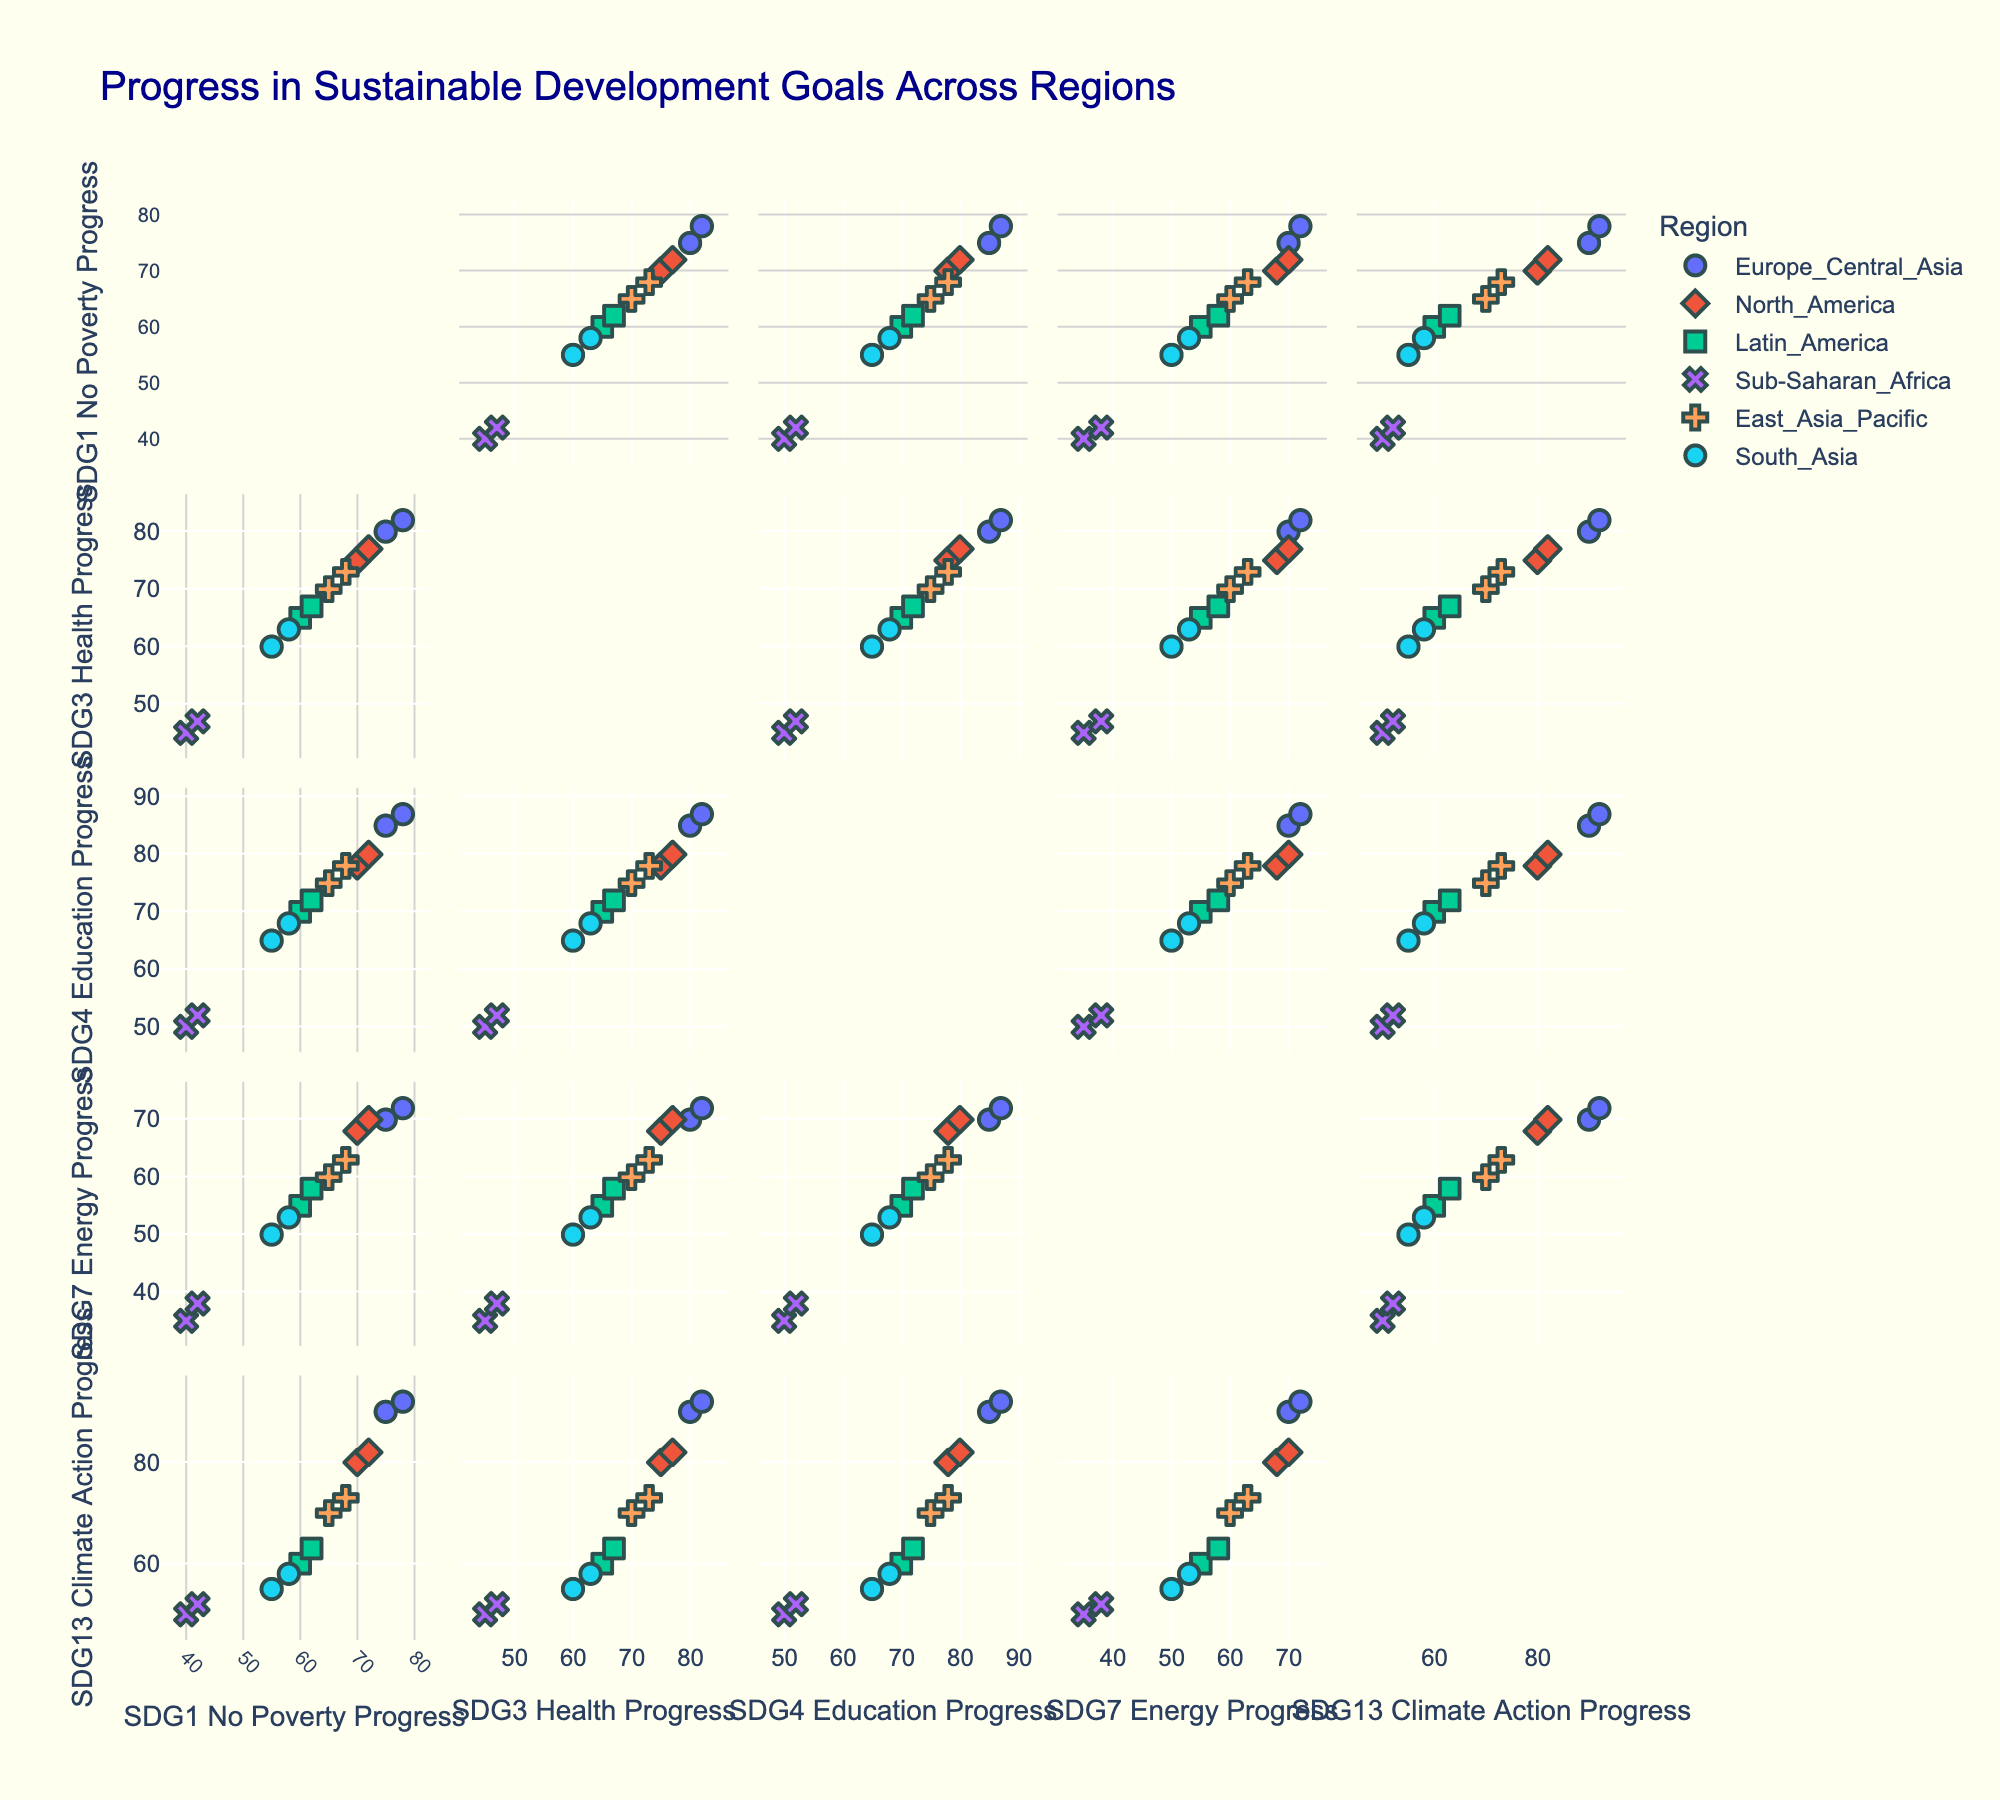What is the title of the figure? The title of the figure is typically displayed at the top of the plot. By looking at the top of the Scatter Plot Matrix (SPLOM), we can read the text indicating the title.
Answer: Progress in Sustainable Development Goals Across Regions How is the `Region` information encoded in the plot? In the Scatter Plot Matrix (SPLOM), the `Region` information is encoded using colors and symbols. Each region is represented by a unique color and symbol, allowing us to distinguish between different regions visually.
Answer: Colors and symbols How many dimensions (columns) are compared in the scatter plot matrix? We can count the number of columns used as dimensions in the Scatter Plot Matrix. The dimensions are shown on the axes of the individual scatter plots within the matrix.
Answer: 5 Which region shows the highest progress in "No Poverty" and "Energy Access" goals in 2019? By looking at the scatter plots with "No Poverty" progress and "Energy Access" progress as axes, we can identify each point and check their hover information for the year. The points belonging to 2019 and which region they are from will help us find the region with the highest progress in both goals.
Answer: East Asia & Pacific Which region shows a noticeable increase in "Education" progress between their two policy implementation dates? By examining the scatter plot for "Education" progress, we can compare the data points for each region between the two implementation dates, noticing changes in progress. The region with a noticeable increase will stand out.
Answer: Europe & Central Asia Is there a clear relationship between "Health Progress" and "Climate Action Progress"? We need to look at the scatter plot comparing "Health Progress" and "Climate Action Progress" across all data points. If the points form a discernible pattern or trend, we can infer whether there's a clear relationship.
Answer: No clear relationship How does "Sub-Saharan Africa" compare to "Latin America" in terms of "Health Progress" improvement? We compare "Health Progress" data points at different policy implementation dates for both Sub-Saharan Africa and Latin America. By calculating the differences or by visual comparison, we can deduce which region improved more.
Answer: Latin America improved more What is the difference in "Climate Action Progress" between East Asia & Pacific and Sub-Saharan Africa in 2015? By identifying the data points for East Asia & Pacific and Sub-Saharan Africa from the year 2015, we compare the "Climate Action Progress" values and deduct the smaller from the larger to find the difference.
Answer: 20 Do any regions progress uniformly across all the Sustainable Development Goals (SDGs)? We would examine the scatter plots for each region and check if the data points for a region form a line or trend that suggests uniform progress across all SDGs. Uniform progress means improvements in one goal are proportionally matched in others.
Answer: No Which region implemented policies early but shows the least progress in "No Poverty"? By looking at implementation dates and cross-referencing with "No Poverty" progress, we identify the region that implemented policies early but shows the lowest progress in this specific goal.
Answer: Sub-Saharan Africa 